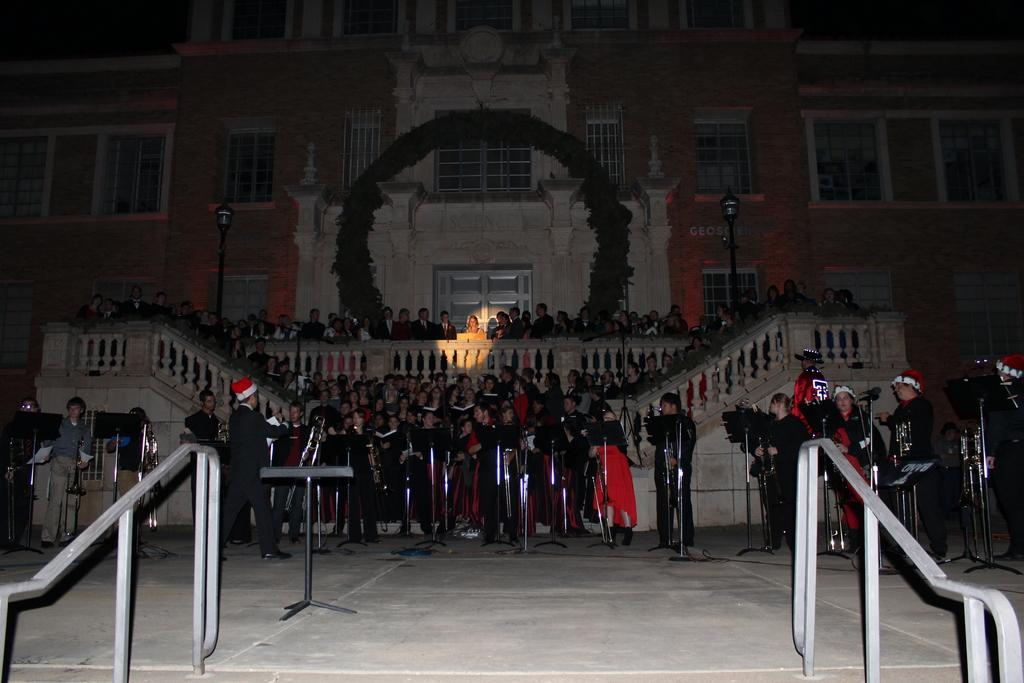What is the main structure in the image? There is a building in the image. What are the people on the building doing? There is a group of people standing on the building. How can people access the building? There are stairs on the building. What is present in the foreground of the image? There is a barrier and mics with stands in the foreground of the image. What type of plough can be seen in the image? There is no plough present in the image. Is there a church visible in the image? No, there is no church visible in the image; it features a building with people standing on it. 